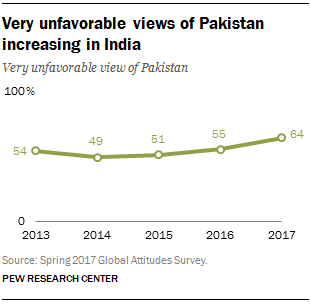Highlight a few significant elements in this photo. The unfavorable view reached its peak in 2017. For how many years has the line been over 50? The line has been over 50 for 4 years. 